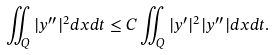<formula> <loc_0><loc_0><loc_500><loc_500>\iint _ { Q } | y ^ { \prime \prime } | ^ { 2 } d x d t \leq C \iint _ { Q } | y ^ { \prime } | ^ { 2 } | y ^ { \prime \prime } | d x d t .</formula> 